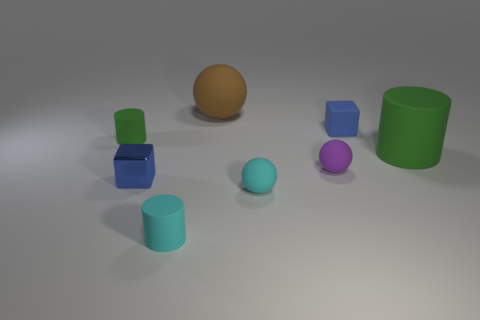What number of objects are green rubber objects that are left of the tiny blue matte cube or large red shiny cubes?
Provide a succinct answer. 1. Is the number of small cyan rubber spheres greater than the number of big red shiny cylinders?
Give a very brief answer. Yes. Are there any purple rubber things that have the same size as the brown rubber thing?
Provide a short and direct response. No. What number of objects are green things that are left of the brown rubber ball or metallic things that are on the left side of the big green thing?
Provide a short and direct response. 2. There is a block in front of the green object that is left of the big brown rubber object; what color is it?
Provide a short and direct response. Blue. What is the color of the other large thing that is made of the same material as the big green thing?
Give a very brief answer. Brown. What number of matte objects are the same color as the large rubber cylinder?
Provide a succinct answer. 1. How many things are purple matte things or big cylinders?
Keep it short and to the point. 2. The green thing that is the same size as the brown matte object is what shape?
Provide a short and direct response. Cylinder. How many things are in front of the blue rubber thing and to the left of the small matte block?
Offer a very short reply. 5. 